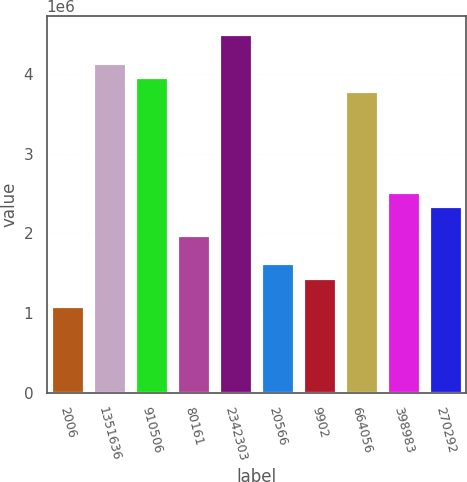Convert chart to OTSL. <chart><loc_0><loc_0><loc_500><loc_500><bar_chart><fcel>2006<fcel>1351636<fcel>910506<fcel>80161<fcel>2342303<fcel>20566<fcel>9902<fcel>664056<fcel>398983<fcel>270292<nl><fcel>1.08133e+06<fcel>4.14512e+06<fcel>3.96489e+06<fcel>1.98245e+06<fcel>4.50556e+06<fcel>1.622e+06<fcel>1.44178e+06<fcel>3.78467e+06<fcel>2.52311e+06<fcel>2.34289e+06<nl></chart> 